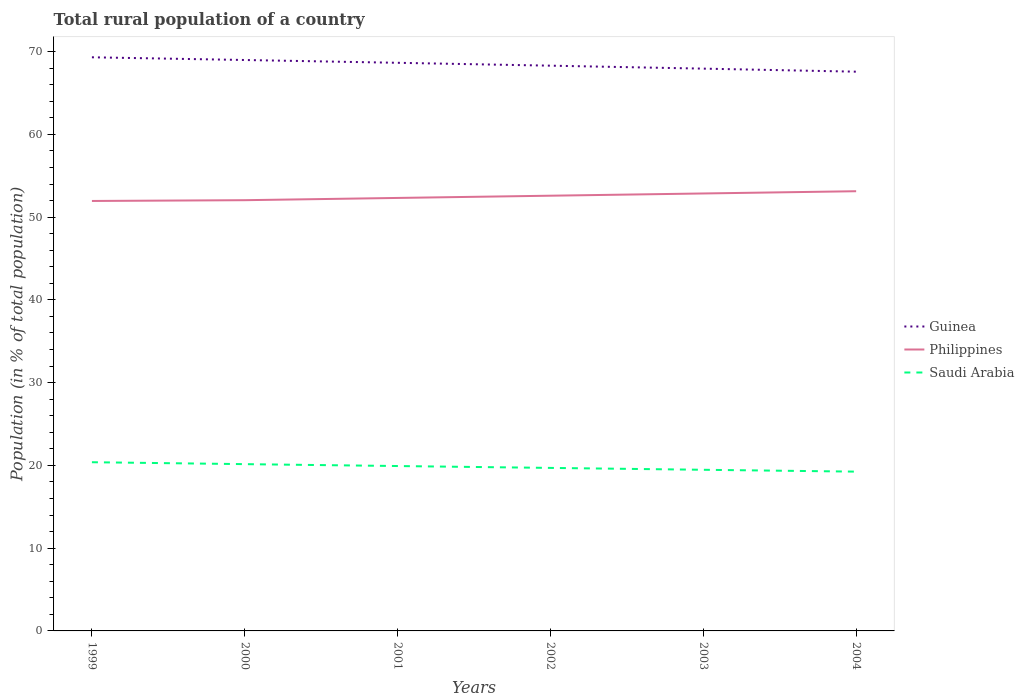Does the line corresponding to Philippines intersect with the line corresponding to Saudi Arabia?
Make the answer very short. No. Across all years, what is the maximum rural population in Philippines?
Offer a very short reply. 51.95. In which year was the rural population in Philippines maximum?
Provide a short and direct response. 1999. What is the total rural population in Philippines in the graph?
Offer a very short reply. -0.27. What is the difference between the highest and the second highest rural population in Saudi Arabia?
Make the answer very short. 1.14. Is the rural population in Guinea strictly greater than the rural population in Philippines over the years?
Ensure brevity in your answer.  No. How many years are there in the graph?
Keep it short and to the point. 6. Where does the legend appear in the graph?
Ensure brevity in your answer.  Center right. How are the legend labels stacked?
Your answer should be compact. Vertical. What is the title of the graph?
Give a very brief answer. Total rural population of a country. Does "Qatar" appear as one of the legend labels in the graph?
Ensure brevity in your answer.  No. What is the label or title of the X-axis?
Keep it short and to the point. Years. What is the label or title of the Y-axis?
Provide a succinct answer. Population (in % of total population). What is the Population (in % of total population) in Guinea in 1999?
Provide a short and direct response. 69.31. What is the Population (in % of total population) in Philippines in 1999?
Keep it short and to the point. 51.95. What is the Population (in % of total population) in Saudi Arabia in 1999?
Ensure brevity in your answer.  20.38. What is the Population (in % of total population) in Guinea in 2000?
Keep it short and to the point. 68.98. What is the Population (in % of total population) in Philippines in 2000?
Give a very brief answer. 52.05. What is the Population (in % of total population) in Saudi Arabia in 2000?
Offer a very short reply. 20.15. What is the Population (in % of total population) in Guinea in 2001?
Ensure brevity in your answer.  68.64. What is the Population (in % of total population) in Philippines in 2001?
Keep it short and to the point. 52.32. What is the Population (in % of total population) in Saudi Arabia in 2001?
Offer a very short reply. 19.92. What is the Population (in % of total population) of Guinea in 2002?
Offer a terse response. 68.3. What is the Population (in % of total population) in Philippines in 2002?
Your response must be concise. 52.59. What is the Population (in % of total population) in Saudi Arabia in 2002?
Provide a short and direct response. 19.7. What is the Population (in % of total population) of Guinea in 2003?
Keep it short and to the point. 67.94. What is the Population (in % of total population) in Philippines in 2003?
Provide a succinct answer. 52.86. What is the Population (in % of total population) in Saudi Arabia in 2003?
Keep it short and to the point. 19.47. What is the Population (in % of total population) in Guinea in 2004?
Your answer should be very brief. 67.57. What is the Population (in % of total population) in Philippines in 2004?
Ensure brevity in your answer.  53.13. What is the Population (in % of total population) of Saudi Arabia in 2004?
Your answer should be very brief. 19.25. Across all years, what is the maximum Population (in % of total population) of Guinea?
Your answer should be compact. 69.31. Across all years, what is the maximum Population (in % of total population) in Philippines?
Provide a succinct answer. 53.13. Across all years, what is the maximum Population (in % of total population) of Saudi Arabia?
Make the answer very short. 20.38. Across all years, what is the minimum Population (in % of total population) of Guinea?
Your response must be concise. 67.57. Across all years, what is the minimum Population (in % of total population) of Philippines?
Make the answer very short. 51.95. Across all years, what is the minimum Population (in % of total population) of Saudi Arabia?
Give a very brief answer. 19.25. What is the total Population (in % of total population) in Guinea in the graph?
Ensure brevity in your answer.  410.75. What is the total Population (in % of total population) in Philippines in the graph?
Provide a succinct answer. 314.88. What is the total Population (in % of total population) in Saudi Arabia in the graph?
Make the answer very short. 118.87. What is the difference between the Population (in % of total population) of Guinea in 1999 and that in 2000?
Make the answer very short. 0.33. What is the difference between the Population (in % of total population) of Philippines in 1999 and that in 2000?
Provide a short and direct response. -0.1. What is the difference between the Population (in % of total population) of Saudi Arabia in 1999 and that in 2000?
Keep it short and to the point. 0.23. What is the difference between the Population (in % of total population) of Guinea in 1999 and that in 2001?
Offer a terse response. 0.67. What is the difference between the Population (in % of total population) in Philippines in 1999 and that in 2001?
Your answer should be very brief. -0.37. What is the difference between the Population (in % of total population) in Saudi Arabia in 1999 and that in 2001?
Keep it short and to the point. 0.46. What is the difference between the Population (in % of total population) of Guinea in 1999 and that in 2002?
Offer a terse response. 1.01. What is the difference between the Population (in % of total population) in Philippines in 1999 and that in 2002?
Give a very brief answer. -0.64. What is the difference between the Population (in % of total population) of Saudi Arabia in 1999 and that in 2002?
Give a very brief answer. 0.69. What is the difference between the Population (in % of total population) in Guinea in 1999 and that in 2003?
Offer a terse response. 1.37. What is the difference between the Population (in % of total population) of Philippines in 1999 and that in 2003?
Give a very brief answer. -0.91. What is the difference between the Population (in % of total population) of Saudi Arabia in 1999 and that in 2003?
Give a very brief answer. 0.91. What is the difference between the Population (in % of total population) in Guinea in 1999 and that in 2004?
Make the answer very short. 1.74. What is the difference between the Population (in % of total population) of Philippines in 1999 and that in 2004?
Ensure brevity in your answer.  -1.18. What is the difference between the Population (in % of total population) of Saudi Arabia in 1999 and that in 2004?
Your answer should be compact. 1.14. What is the difference between the Population (in % of total population) in Guinea in 2000 and that in 2001?
Make the answer very short. 0.34. What is the difference between the Population (in % of total population) of Philippines in 2000 and that in 2001?
Your answer should be compact. -0.27. What is the difference between the Population (in % of total population) of Saudi Arabia in 2000 and that in 2001?
Provide a succinct answer. 0.23. What is the difference between the Population (in % of total population) in Guinea in 2000 and that in 2002?
Provide a succinct answer. 0.69. What is the difference between the Population (in % of total population) in Philippines in 2000 and that in 2002?
Ensure brevity in your answer.  -0.54. What is the difference between the Population (in % of total population) in Saudi Arabia in 2000 and that in 2002?
Make the answer very short. 0.46. What is the difference between the Population (in % of total population) of Guinea in 2000 and that in 2003?
Provide a succinct answer. 1.04. What is the difference between the Population (in % of total population) in Philippines in 2000 and that in 2003?
Provide a succinct answer. -0.81. What is the difference between the Population (in % of total population) of Saudi Arabia in 2000 and that in 2003?
Offer a very short reply. 0.68. What is the difference between the Population (in % of total population) of Guinea in 2000 and that in 2004?
Offer a very short reply. 1.41. What is the difference between the Population (in % of total population) of Philippines in 2000 and that in 2004?
Offer a very short reply. -1.08. What is the difference between the Population (in % of total population) of Saudi Arabia in 2000 and that in 2004?
Your response must be concise. 0.91. What is the difference between the Population (in % of total population) of Guinea in 2001 and that in 2002?
Ensure brevity in your answer.  0.35. What is the difference between the Population (in % of total population) in Philippines in 2001 and that in 2002?
Make the answer very short. -0.27. What is the difference between the Population (in % of total population) of Saudi Arabia in 2001 and that in 2002?
Offer a very short reply. 0.23. What is the difference between the Population (in % of total population) of Guinea in 2001 and that in 2003?
Provide a short and direct response. 0.7. What is the difference between the Population (in % of total population) of Philippines in 2001 and that in 2003?
Your answer should be very brief. -0.54. What is the difference between the Population (in % of total population) of Saudi Arabia in 2001 and that in 2003?
Ensure brevity in your answer.  0.45. What is the difference between the Population (in % of total population) of Guinea in 2001 and that in 2004?
Provide a succinct answer. 1.07. What is the difference between the Population (in % of total population) in Philippines in 2001 and that in 2004?
Provide a succinct answer. -0.81. What is the difference between the Population (in % of total population) in Saudi Arabia in 2001 and that in 2004?
Your answer should be very brief. 0.68. What is the difference between the Population (in % of total population) in Guinea in 2002 and that in 2003?
Offer a very short reply. 0.36. What is the difference between the Population (in % of total population) in Philippines in 2002 and that in 2003?
Offer a very short reply. -0.27. What is the difference between the Population (in % of total population) in Saudi Arabia in 2002 and that in 2003?
Your response must be concise. 0.23. What is the difference between the Population (in % of total population) in Guinea in 2002 and that in 2004?
Ensure brevity in your answer.  0.73. What is the difference between the Population (in % of total population) of Philippines in 2002 and that in 2004?
Your answer should be very brief. -0.54. What is the difference between the Population (in % of total population) of Saudi Arabia in 2002 and that in 2004?
Keep it short and to the point. 0.45. What is the difference between the Population (in % of total population) in Guinea in 2003 and that in 2004?
Make the answer very short. 0.37. What is the difference between the Population (in % of total population) of Philippines in 2003 and that in 2004?
Your response must be concise. -0.27. What is the difference between the Population (in % of total population) in Saudi Arabia in 2003 and that in 2004?
Your response must be concise. 0.22. What is the difference between the Population (in % of total population) of Guinea in 1999 and the Population (in % of total population) of Philippines in 2000?
Your response must be concise. 17.27. What is the difference between the Population (in % of total population) in Guinea in 1999 and the Population (in % of total population) in Saudi Arabia in 2000?
Provide a short and direct response. 49.16. What is the difference between the Population (in % of total population) in Philippines in 1999 and the Population (in % of total population) in Saudi Arabia in 2000?
Your response must be concise. 31.8. What is the difference between the Population (in % of total population) of Guinea in 1999 and the Population (in % of total population) of Philippines in 2001?
Provide a short and direct response. 16.99. What is the difference between the Population (in % of total population) in Guinea in 1999 and the Population (in % of total population) in Saudi Arabia in 2001?
Ensure brevity in your answer.  49.39. What is the difference between the Population (in % of total population) of Philippines in 1999 and the Population (in % of total population) of Saudi Arabia in 2001?
Offer a terse response. 32.03. What is the difference between the Population (in % of total population) in Guinea in 1999 and the Population (in % of total population) in Philippines in 2002?
Make the answer very short. 16.72. What is the difference between the Population (in % of total population) in Guinea in 1999 and the Population (in % of total population) in Saudi Arabia in 2002?
Your answer should be compact. 49.61. What is the difference between the Population (in % of total population) of Philippines in 1999 and the Population (in % of total population) of Saudi Arabia in 2002?
Give a very brief answer. 32.25. What is the difference between the Population (in % of total population) of Guinea in 1999 and the Population (in % of total population) of Philippines in 2003?
Offer a terse response. 16.45. What is the difference between the Population (in % of total population) of Guinea in 1999 and the Population (in % of total population) of Saudi Arabia in 2003?
Provide a short and direct response. 49.84. What is the difference between the Population (in % of total population) of Philippines in 1999 and the Population (in % of total population) of Saudi Arabia in 2003?
Make the answer very short. 32.48. What is the difference between the Population (in % of total population) of Guinea in 1999 and the Population (in % of total population) of Philippines in 2004?
Offer a terse response. 16.18. What is the difference between the Population (in % of total population) in Guinea in 1999 and the Population (in % of total population) in Saudi Arabia in 2004?
Ensure brevity in your answer.  50.06. What is the difference between the Population (in % of total population) in Philippines in 1999 and the Population (in % of total population) in Saudi Arabia in 2004?
Make the answer very short. 32.7. What is the difference between the Population (in % of total population) in Guinea in 2000 and the Population (in % of total population) in Philippines in 2001?
Make the answer very short. 16.67. What is the difference between the Population (in % of total population) of Guinea in 2000 and the Population (in % of total population) of Saudi Arabia in 2001?
Ensure brevity in your answer.  49.06. What is the difference between the Population (in % of total population) in Philippines in 2000 and the Population (in % of total population) in Saudi Arabia in 2001?
Offer a very short reply. 32.12. What is the difference between the Population (in % of total population) in Guinea in 2000 and the Population (in % of total population) in Philippines in 2002?
Your answer should be compact. 16.4. What is the difference between the Population (in % of total population) in Guinea in 2000 and the Population (in % of total population) in Saudi Arabia in 2002?
Provide a succinct answer. 49.29. What is the difference between the Population (in % of total population) in Philippines in 2000 and the Population (in % of total population) in Saudi Arabia in 2002?
Offer a terse response. 32.35. What is the difference between the Population (in % of total population) of Guinea in 2000 and the Population (in % of total population) of Philippines in 2003?
Make the answer very short. 16.13. What is the difference between the Population (in % of total population) of Guinea in 2000 and the Population (in % of total population) of Saudi Arabia in 2003?
Keep it short and to the point. 49.51. What is the difference between the Population (in % of total population) of Philippines in 2000 and the Population (in % of total population) of Saudi Arabia in 2003?
Provide a succinct answer. 32.58. What is the difference between the Population (in % of total population) in Guinea in 2000 and the Population (in % of total population) in Philippines in 2004?
Offer a terse response. 15.86. What is the difference between the Population (in % of total population) of Guinea in 2000 and the Population (in % of total population) of Saudi Arabia in 2004?
Your answer should be compact. 49.74. What is the difference between the Population (in % of total population) in Philippines in 2000 and the Population (in % of total population) in Saudi Arabia in 2004?
Your response must be concise. 32.8. What is the difference between the Population (in % of total population) in Guinea in 2001 and the Population (in % of total population) in Philippines in 2002?
Make the answer very short. 16.06. What is the difference between the Population (in % of total population) of Guinea in 2001 and the Population (in % of total population) of Saudi Arabia in 2002?
Offer a terse response. 48.95. What is the difference between the Population (in % of total population) in Philippines in 2001 and the Population (in % of total population) in Saudi Arabia in 2002?
Your response must be concise. 32.62. What is the difference between the Population (in % of total population) of Guinea in 2001 and the Population (in % of total population) of Philippines in 2003?
Your response must be concise. 15.79. What is the difference between the Population (in % of total population) of Guinea in 2001 and the Population (in % of total population) of Saudi Arabia in 2003?
Give a very brief answer. 49.17. What is the difference between the Population (in % of total population) of Philippines in 2001 and the Population (in % of total population) of Saudi Arabia in 2003?
Keep it short and to the point. 32.85. What is the difference between the Population (in % of total population) of Guinea in 2001 and the Population (in % of total population) of Philippines in 2004?
Ensure brevity in your answer.  15.52. What is the difference between the Population (in % of total population) in Guinea in 2001 and the Population (in % of total population) in Saudi Arabia in 2004?
Your response must be concise. 49.4. What is the difference between the Population (in % of total population) in Philippines in 2001 and the Population (in % of total population) in Saudi Arabia in 2004?
Your answer should be compact. 33.07. What is the difference between the Population (in % of total population) in Guinea in 2002 and the Population (in % of total population) in Philippines in 2003?
Keep it short and to the point. 15.44. What is the difference between the Population (in % of total population) in Guinea in 2002 and the Population (in % of total population) in Saudi Arabia in 2003?
Provide a short and direct response. 48.83. What is the difference between the Population (in % of total population) in Philippines in 2002 and the Population (in % of total population) in Saudi Arabia in 2003?
Your response must be concise. 33.12. What is the difference between the Population (in % of total population) in Guinea in 2002 and the Population (in % of total population) in Philippines in 2004?
Ensure brevity in your answer.  15.17. What is the difference between the Population (in % of total population) in Guinea in 2002 and the Population (in % of total population) in Saudi Arabia in 2004?
Provide a short and direct response. 49.05. What is the difference between the Population (in % of total population) in Philippines in 2002 and the Population (in % of total population) in Saudi Arabia in 2004?
Keep it short and to the point. 33.34. What is the difference between the Population (in % of total population) of Guinea in 2003 and the Population (in % of total population) of Philippines in 2004?
Keep it short and to the point. 14.81. What is the difference between the Population (in % of total population) of Guinea in 2003 and the Population (in % of total population) of Saudi Arabia in 2004?
Your answer should be very brief. 48.69. What is the difference between the Population (in % of total population) in Philippines in 2003 and the Population (in % of total population) in Saudi Arabia in 2004?
Give a very brief answer. 33.61. What is the average Population (in % of total population) of Guinea per year?
Provide a succinct answer. 68.46. What is the average Population (in % of total population) in Philippines per year?
Offer a very short reply. 52.48. What is the average Population (in % of total population) in Saudi Arabia per year?
Provide a succinct answer. 19.81. In the year 1999, what is the difference between the Population (in % of total population) of Guinea and Population (in % of total population) of Philippines?
Offer a terse response. 17.36. In the year 1999, what is the difference between the Population (in % of total population) in Guinea and Population (in % of total population) in Saudi Arabia?
Offer a very short reply. 48.93. In the year 1999, what is the difference between the Population (in % of total population) in Philippines and Population (in % of total population) in Saudi Arabia?
Your answer should be compact. 31.57. In the year 2000, what is the difference between the Population (in % of total population) in Guinea and Population (in % of total population) in Philippines?
Keep it short and to the point. 16.94. In the year 2000, what is the difference between the Population (in % of total population) of Guinea and Population (in % of total population) of Saudi Arabia?
Your answer should be compact. 48.83. In the year 2000, what is the difference between the Population (in % of total population) of Philippines and Population (in % of total population) of Saudi Arabia?
Provide a short and direct response. 31.89. In the year 2001, what is the difference between the Population (in % of total population) of Guinea and Population (in % of total population) of Philippines?
Your response must be concise. 16.33. In the year 2001, what is the difference between the Population (in % of total population) in Guinea and Population (in % of total population) in Saudi Arabia?
Your answer should be compact. 48.72. In the year 2001, what is the difference between the Population (in % of total population) of Philippines and Population (in % of total population) of Saudi Arabia?
Offer a very short reply. 32.39. In the year 2002, what is the difference between the Population (in % of total population) in Guinea and Population (in % of total population) in Philippines?
Your answer should be very brief. 15.71. In the year 2002, what is the difference between the Population (in % of total population) of Guinea and Population (in % of total population) of Saudi Arabia?
Your response must be concise. 48.6. In the year 2002, what is the difference between the Population (in % of total population) of Philippines and Population (in % of total population) of Saudi Arabia?
Give a very brief answer. 32.89. In the year 2003, what is the difference between the Population (in % of total population) of Guinea and Population (in % of total population) of Philippines?
Give a very brief answer. 15.08. In the year 2003, what is the difference between the Population (in % of total population) of Guinea and Population (in % of total population) of Saudi Arabia?
Ensure brevity in your answer.  48.47. In the year 2003, what is the difference between the Population (in % of total population) of Philippines and Population (in % of total population) of Saudi Arabia?
Your answer should be compact. 33.39. In the year 2004, what is the difference between the Population (in % of total population) of Guinea and Population (in % of total population) of Philippines?
Ensure brevity in your answer.  14.44. In the year 2004, what is the difference between the Population (in % of total population) in Guinea and Population (in % of total population) in Saudi Arabia?
Give a very brief answer. 48.33. In the year 2004, what is the difference between the Population (in % of total population) in Philippines and Population (in % of total population) in Saudi Arabia?
Your answer should be very brief. 33.88. What is the ratio of the Population (in % of total population) of Guinea in 1999 to that in 2000?
Your response must be concise. 1. What is the ratio of the Population (in % of total population) in Philippines in 1999 to that in 2000?
Your answer should be compact. 1. What is the ratio of the Population (in % of total population) of Saudi Arabia in 1999 to that in 2000?
Your answer should be very brief. 1.01. What is the ratio of the Population (in % of total population) of Guinea in 1999 to that in 2001?
Keep it short and to the point. 1.01. What is the ratio of the Population (in % of total population) in Philippines in 1999 to that in 2001?
Give a very brief answer. 0.99. What is the ratio of the Population (in % of total population) in Saudi Arabia in 1999 to that in 2001?
Your answer should be very brief. 1.02. What is the ratio of the Population (in % of total population) of Guinea in 1999 to that in 2002?
Provide a succinct answer. 1.01. What is the ratio of the Population (in % of total population) in Philippines in 1999 to that in 2002?
Keep it short and to the point. 0.99. What is the ratio of the Population (in % of total population) in Saudi Arabia in 1999 to that in 2002?
Ensure brevity in your answer.  1.03. What is the ratio of the Population (in % of total population) of Guinea in 1999 to that in 2003?
Your answer should be compact. 1.02. What is the ratio of the Population (in % of total population) of Philippines in 1999 to that in 2003?
Your response must be concise. 0.98. What is the ratio of the Population (in % of total population) in Saudi Arabia in 1999 to that in 2003?
Offer a very short reply. 1.05. What is the ratio of the Population (in % of total population) of Guinea in 1999 to that in 2004?
Make the answer very short. 1.03. What is the ratio of the Population (in % of total population) of Philippines in 1999 to that in 2004?
Ensure brevity in your answer.  0.98. What is the ratio of the Population (in % of total population) in Saudi Arabia in 1999 to that in 2004?
Provide a succinct answer. 1.06. What is the ratio of the Population (in % of total population) of Saudi Arabia in 2000 to that in 2001?
Provide a short and direct response. 1.01. What is the ratio of the Population (in % of total population) of Guinea in 2000 to that in 2002?
Make the answer very short. 1.01. What is the ratio of the Population (in % of total population) in Philippines in 2000 to that in 2002?
Your answer should be compact. 0.99. What is the ratio of the Population (in % of total population) in Saudi Arabia in 2000 to that in 2002?
Your answer should be compact. 1.02. What is the ratio of the Population (in % of total population) in Guinea in 2000 to that in 2003?
Make the answer very short. 1.02. What is the ratio of the Population (in % of total population) in Philippines in 2000 to that in 2003?
Your response must be concise. 0.98. What is the ratio of the Population (in % of total population) in Saudi Arabia in 2000 to that in 2003?
Your response must be concise. 1.03. What is the ratio of the Population (in % of total population) in Guinea in 2000 to that in 2004?
Your response must be concise. 1.02. What is the ratio of the Population (in % of total population) in Philippines in 2000 to that in 2004?
Provide a short and direct response. 0.98. What is the ratio of the Population (in % of total population) in Saudi Arabia in 2000 to that in 2004?
Ensure brevity in your answer.  1.05. What is the ratio of the Population (in % of total population) of Philippines in 2001 to that in 2002?
Your answer should be compact. 0.99. What is the ratio of the Population (in % of total population) in Saudi Arabia in 2001 to that in 2002?
Ensure brevity in your answer.  1.01. What is the ratio of the Population (in % of total population) in Guinea in 2001 to that in 2003?
Ensure brevity in your answer.  1.01. What is the ratio of the Population (in % of total population) in Philippines in 2001 to that in 2003?
Keep it short and to the point. 0.99. What is the ratio of the Population (in % of total population) of Saudi Arabia in 2001 to that in 2003?
Your answer should be compact. 1.02. What is the ratio of the Population (in % of total population) of Guinea in 2001 to that in 2004?
Keep it short and to the point. 1.02. What is the ratio of the Population (in % of total population) of Philippines in 2001 to that in 2004?
Ensure brevity in your answer.  0.98. What is the ratio of the Population (in % of total population) in Saudi Arabia in 2001 to that in 2004?
Make the answer very short. 1.04. What is the ratio of the Population (in % of total population) in Guinea in 2002 to that in 2003?
Offer a very short reply. 1.01. What is the ratio of the Population (in % of total population) in Philippines in 2002 to that in 2003?
Offer a very short reply. 0.99. What is the ratio of the Population (in % of total population) in Saudi Arabia in 2002 to that in 2003?
Keep it short and to the point. 1.01. What is the ratio of the Population (in % of total population) in Guinea in 2002 to that in 2004?
Your answer should be compact. 1.01. What is the ratio of the Population (in % of total population) of Philippines in 2002 to that in 2004?
Keep it short and to the point. 0.99. What is the ratio of the Population (in % of total population) of Saudi Arabia in 2002 to that in 2004?
Provide a succinct answer. 1.02. What is the ratio of the Population (in % of total population) in Guinea in 2003 to that in 2004?
Provide a short and direct response. 1.01. What is the ratio of the Population (in % of total population) of Saudi Arabia in 2003 to that in 2004?
Keep it short and to the point. 1.01. What is the difference between the highest and the second highest Population (in % of total population) in Guinea?
Your answer should be compact. 0.33. What is the difference between the highest and the second highest Population (in % of total population) of Philippines?
Provide a short and direct response. 0.27. What is the difference between the highest and the second highest Population (in % of total population) of Saudi Arabia?
Your answer should be very brief. 0.23. What is the difference between the highest and the lowest Population (in % of total population) in Guinea?
Ensure brevity in your answer.  1.74. What is the difference between the highest and the lowest Population (in % of total population) of Philippines?
Provide a succinct answer. 1.18. What is the difference between the highest and the lowest Population (in % of total population) of Saudi Arabia?
Offer a very short reply. 1.14. 